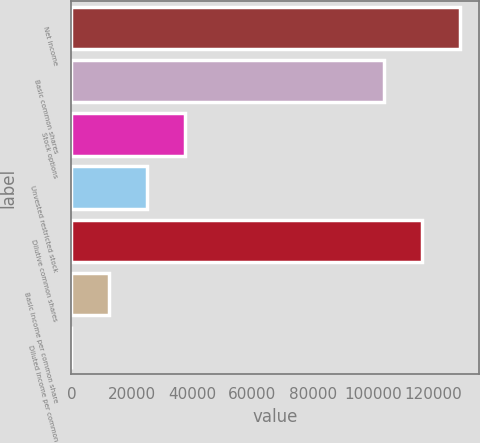Convert chart to OTSL. <chart><loc_0><loc_0><loc_500><loc_500><bar_chart><fcel>Net income<fcel>Basic common shares<fcel>Stock options<fcel>Unvested restricted stock<fcel>Dilutive common shares<fcel>Basic income per common share<fcel>Diluted income per common<nl><fcel>128605<fcel>103599<fcel>37510.4<fcel>25007.4<fcel>116102<fcel>12504.3<fcel>1.2<nl></chart> 